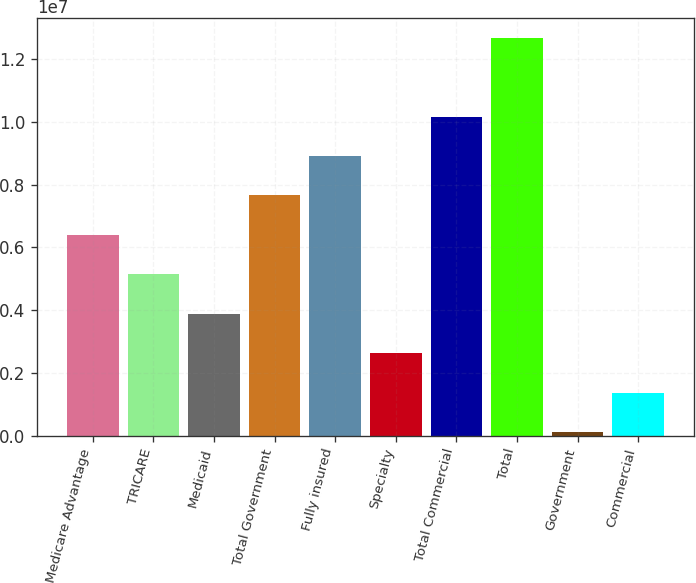<chart> <loc_0><loc_0><loc_500><loc_500><bar_chart><fcel>Medicare Advantage<fcel>TRICARE<fcel>Medicaid<fcel>Total Government<fcel>Fully insured<fcel>Specialty<fcel>Total Commercial<fcel>Total<fcel>Government<fcel>Commercial<nl><fcel>6.3981e+06<fcel>5.13983e+06<fcel>3.88156e+06<fcel>7.65636e+06<fcel>8.91463e+06<fcel>2.6233e+06<fcel>1.01729e+07<fcel>1.26894e+07<fcel>106764<fcel>1.36503e+06<nl></chart> 